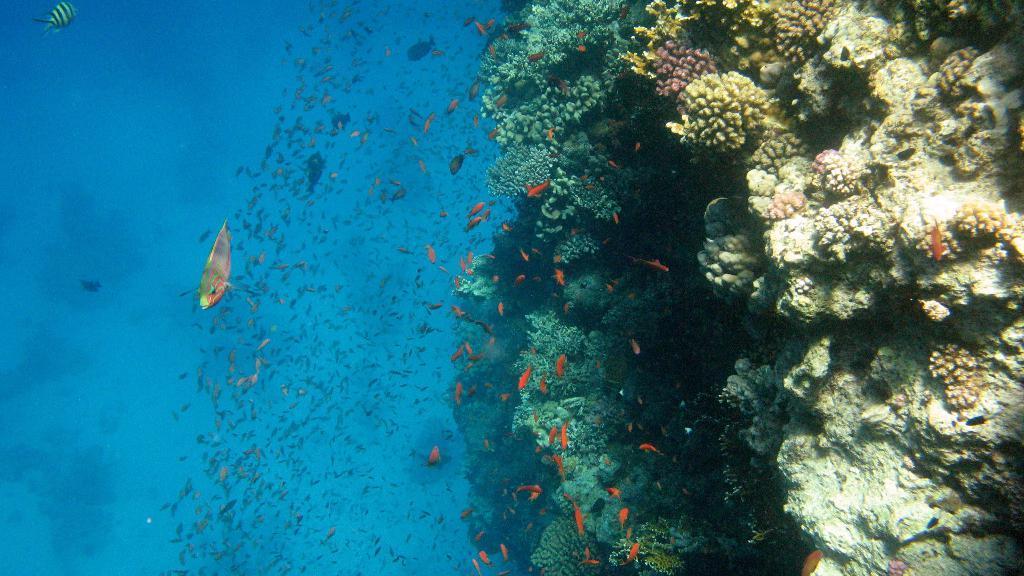Could you give a brief overview of what you see in this image? In this picture I can see the fishes in the water, on the right side those look like marine organisms. 